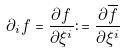<formula> <loc_0><loc_0><loc_500><loc_500>\partial _ { i } f = \frac { \partial f } { \partial \xi ^ { i } } \colon = \frac { \partial \overline { f } } { \partial \xi ^ { i } }</formula> 